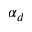Convert formula to latex. <formula><loc_0><loc_0><loc_500><loc_500>\alpha _ { d }</formula> 